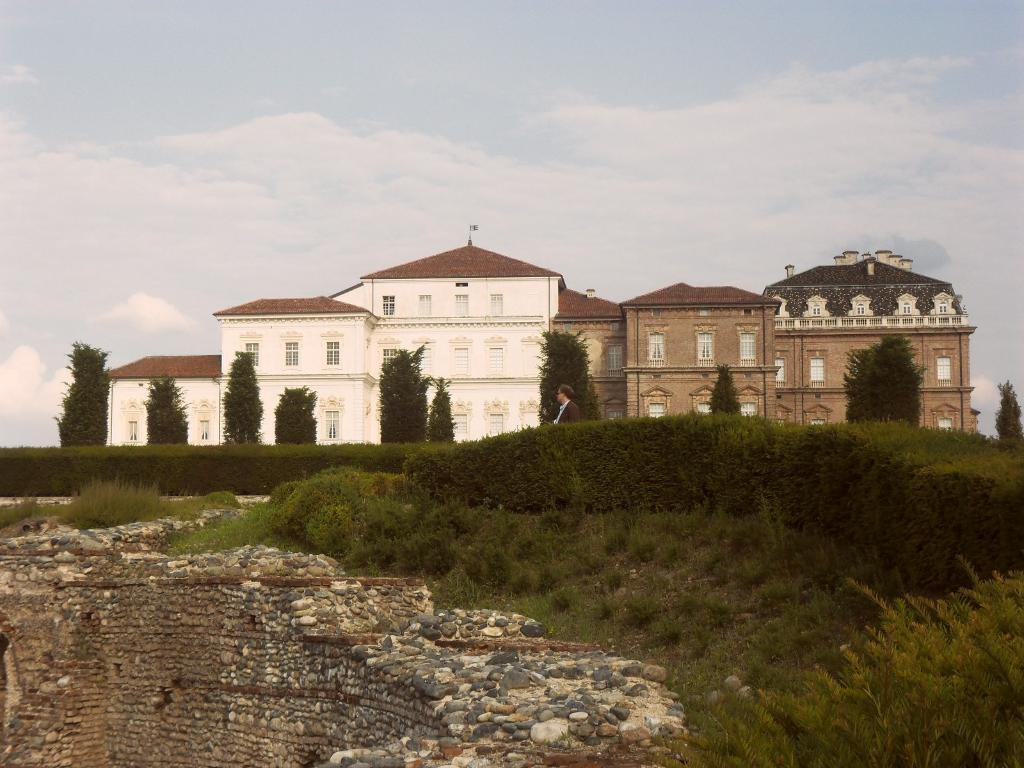What type of structure is visible in the image? There is a building in the image. What is located in front of the building? There are trees and bushes in front of the building. Can you describe the person in front of the building? There is a person in front of the building, but their appearance or actions are not specified. Is there any indication of a wall in front of the building? It is mentioned that there may be a stone wall in front of the building, but it is not definitively confirmed. What can be seen at the top of the image? The sky is visible at the top of the image. What hobbies does the light bulb enjoy in the image? There is no light bulb present in the image, so it is not possible to determine its hobbies. 